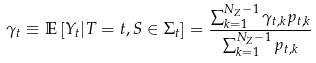<formula> <loc_0><loc_0><loc_500><loc_500>\gamma _ { t } \equiv \mathbb { E } \left [ Y _ { t } | T = t , S \in \Sigma _ { t } \right ] = \frac { \sum _ { k = 1 } ^ { N _ { Z } - 1 } \gamma _ { t , k } p _ { t , k } } { \sum _ { k = 1 } ^ { N _ { Z } - 1 } p _ { t , k } }</formula> 